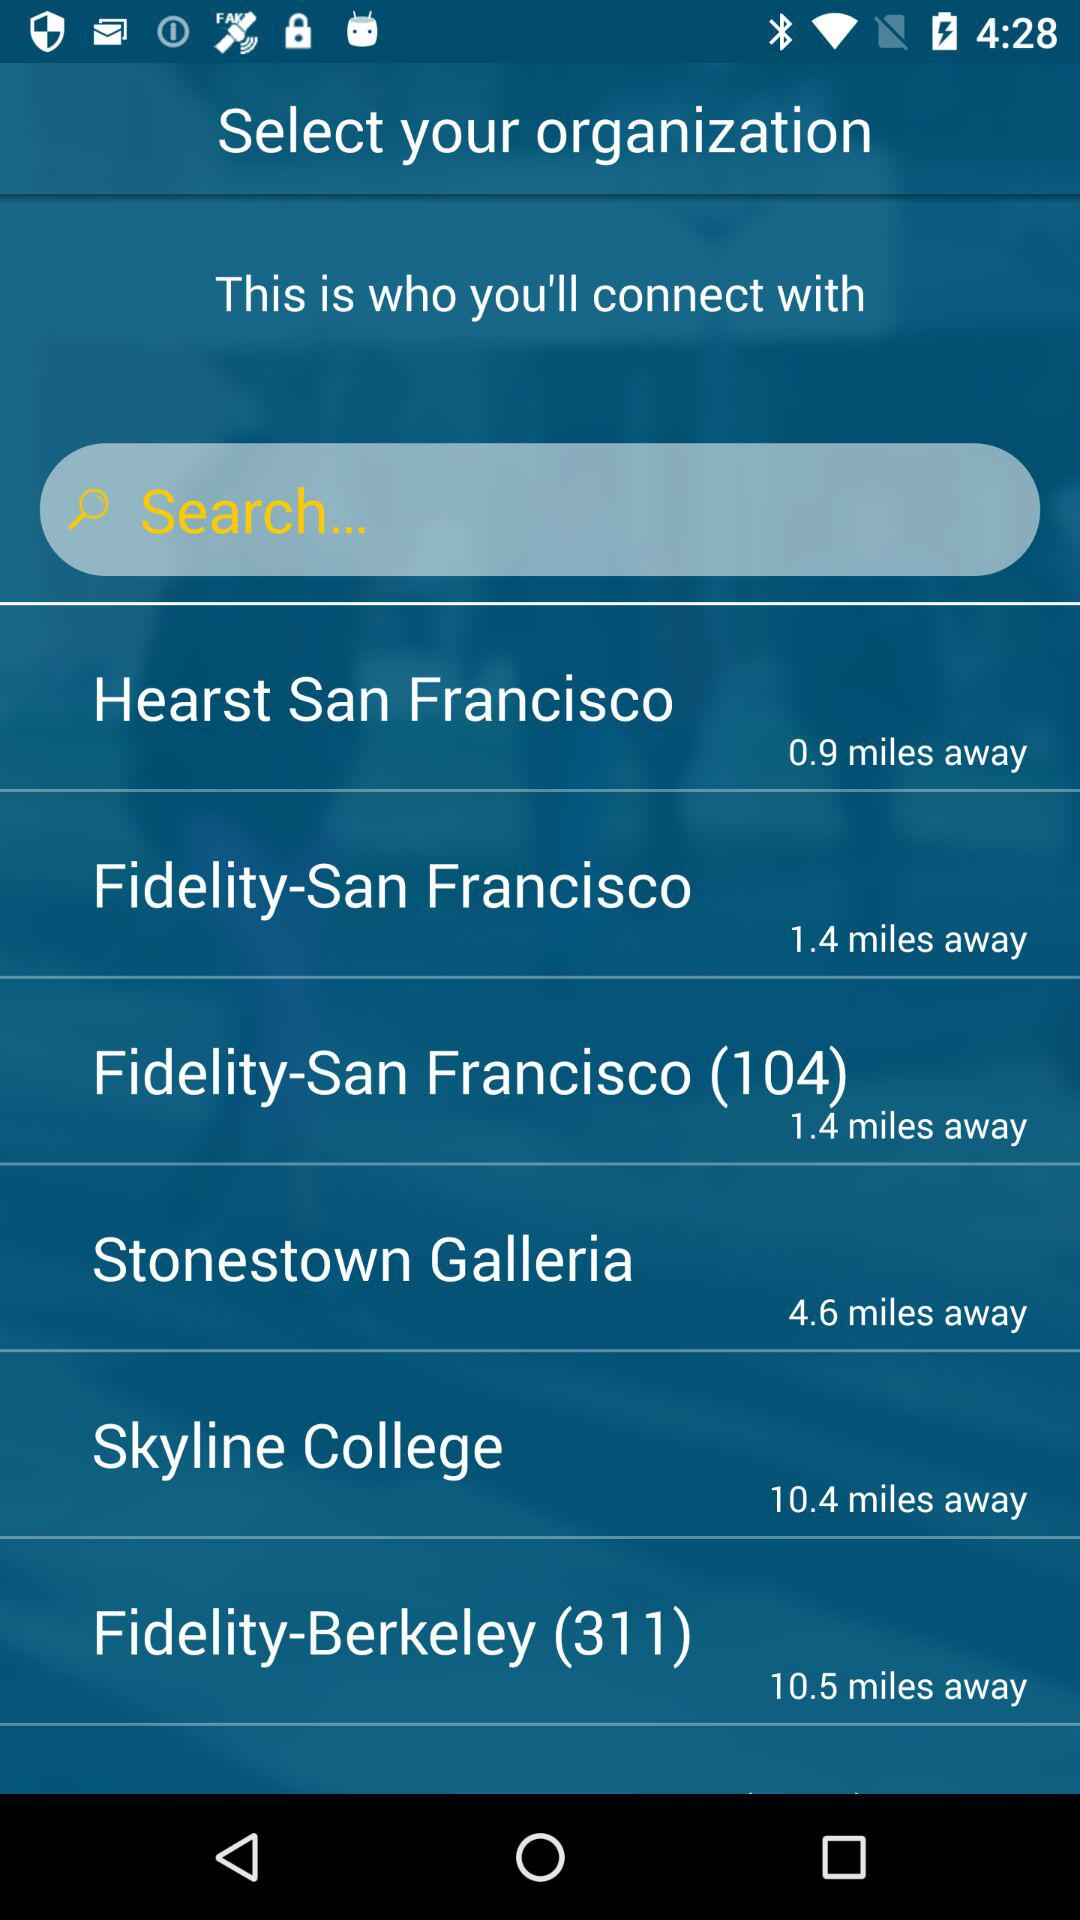How far away is Hearst San Francisco? The Hearst San Francisco is 0.9 miles away. 